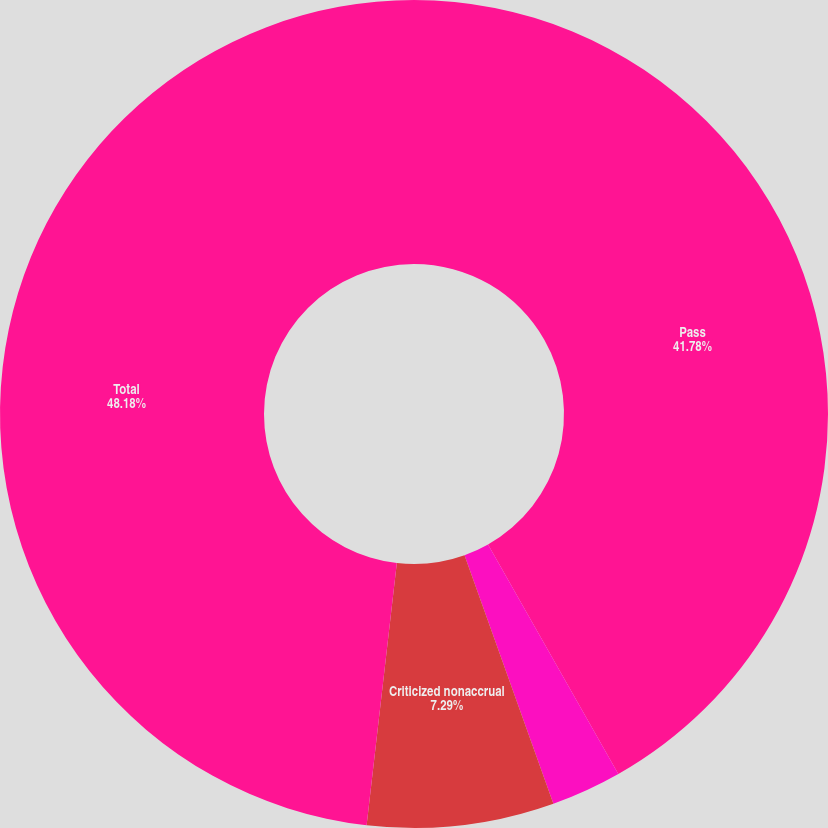Convert chart to OTSL. <chart><loc_0><loc_0><loc_500><loc_500><pie_chart><fcel>Pass<fcel>Criticized accrual<fcel>Criticized nonaccrual<fcel>Total<nl><fcel>41.78%<fcel>2.75%<fcel>7.29%<fcel>48.17%<nl></chart> 